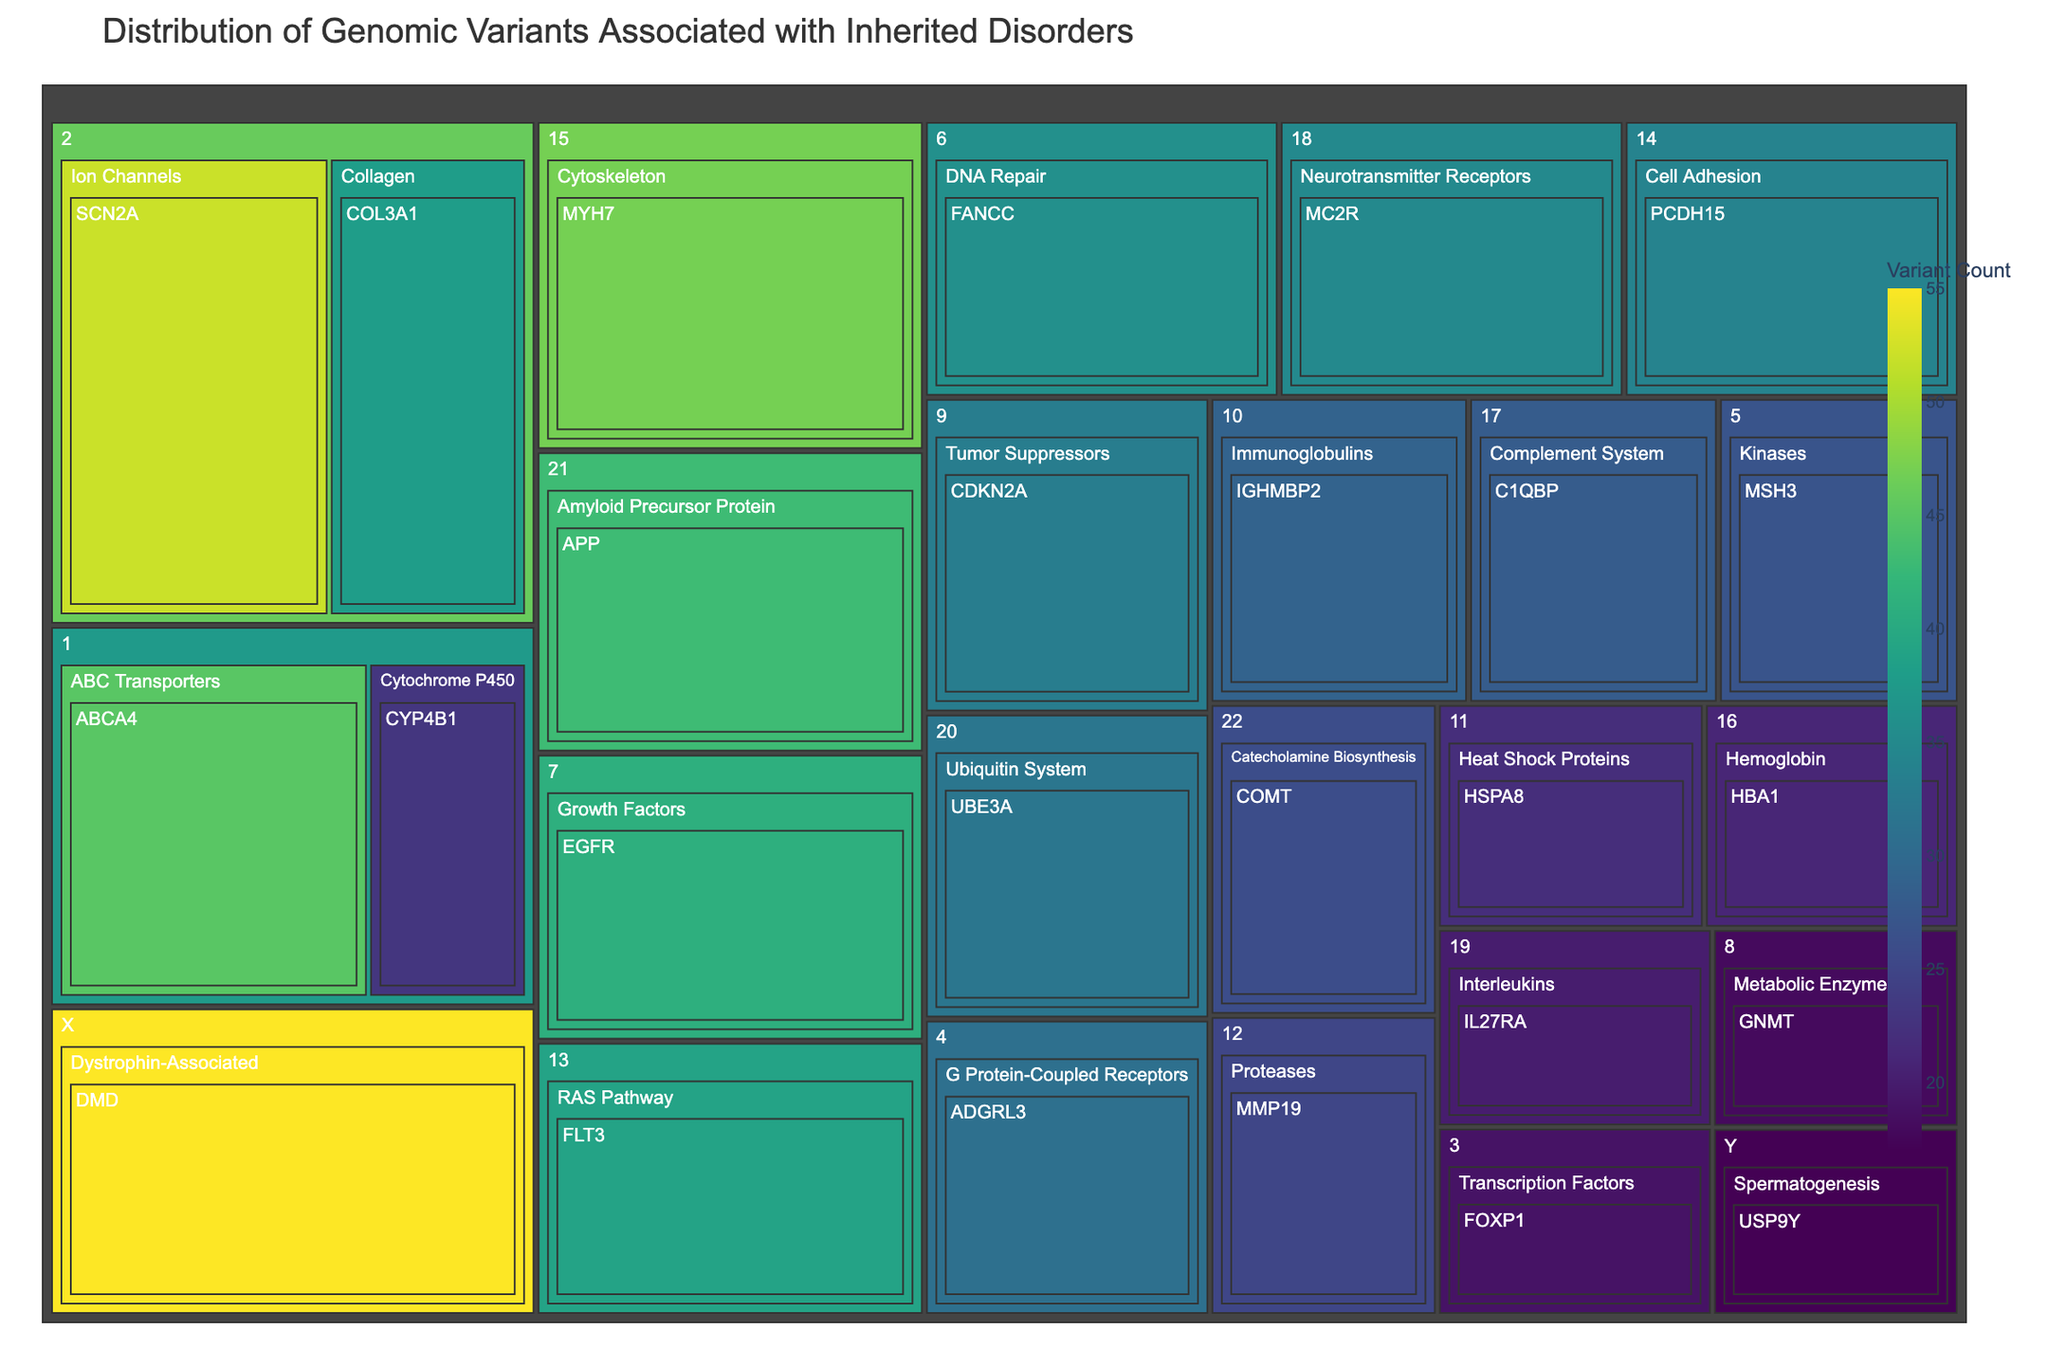What is the title of the figure? The title of the figure is displayed at the top and usually describes the main focus of the visualization. In this case, the title is "Distribution of Genomic Variants Associated with Inherited Disorders".
Answer: Distribution of Genomic Variants Associated with Inherited Disorders Which chromosome is associated with the highest variant count for a single gene? The treemap visually displays variant counts using color and size. The gene DMD on chromosome X has the highest variant count with 55.
Answer: Chromosome X What are the variant counts for genes in the "Collagen" gene family? Select the "Collagen" gene family in the treemap, where you will find the gene COL3A1 with a variant count of 38.
Answer: 38 Which gene family has the most variants in chromosome 15? By looking at chromosome 15 in the treemap, you can find the gene family "Cytoskeleton" with the gene MYH7 having 47 variant counts, the highest for chromosome 15.
Answer: Cytoskeleton How many total variants are associated with chromosome 1? Find the variant counts for each gene in chromosome 1: ABCA4 (45) and CYP4B1 (23), then sum them up: 45 + 23 = 68
Answer: 68 Which has more variants, "Tumor Suppressors" on chromosome 9 or "G Protein-Coupled Receptors" on chromosome 4? Compare the "Tumor Suppressors" variant count (33) on chromosome 9 with the "G Protein-Coupled Receptors" variant count (31) on chromosome 4. 33 is greater than 31.
Answer: Tumor Suppressors Which gene family has the broadest distribution across different chromosomes? By observing the treemap, you can see each gene family across several chromosomes. "ABC Transporters," "Cytochrome P450," and "Collagen" appear only once each, meaning the distributions are similar.
Answer: Equal distribution among displayed families What's the average variant count for gene families on chromosome 8 and chromosome 12? The counts are 18 for GNMT on chromosome 8 and 25 for MMP19 on chromosome 12. The average is (18 + 25) / 2 = 21.5
Answer: 21.5 Which chromosome contains the gene associated with the "Heat Shock Proteins" gene family? Locate the gene family "Heat Shock Proteins" in the treemap and find the corresponding chromosome, which is chromosome 11.
Answer: Chromosome 11 